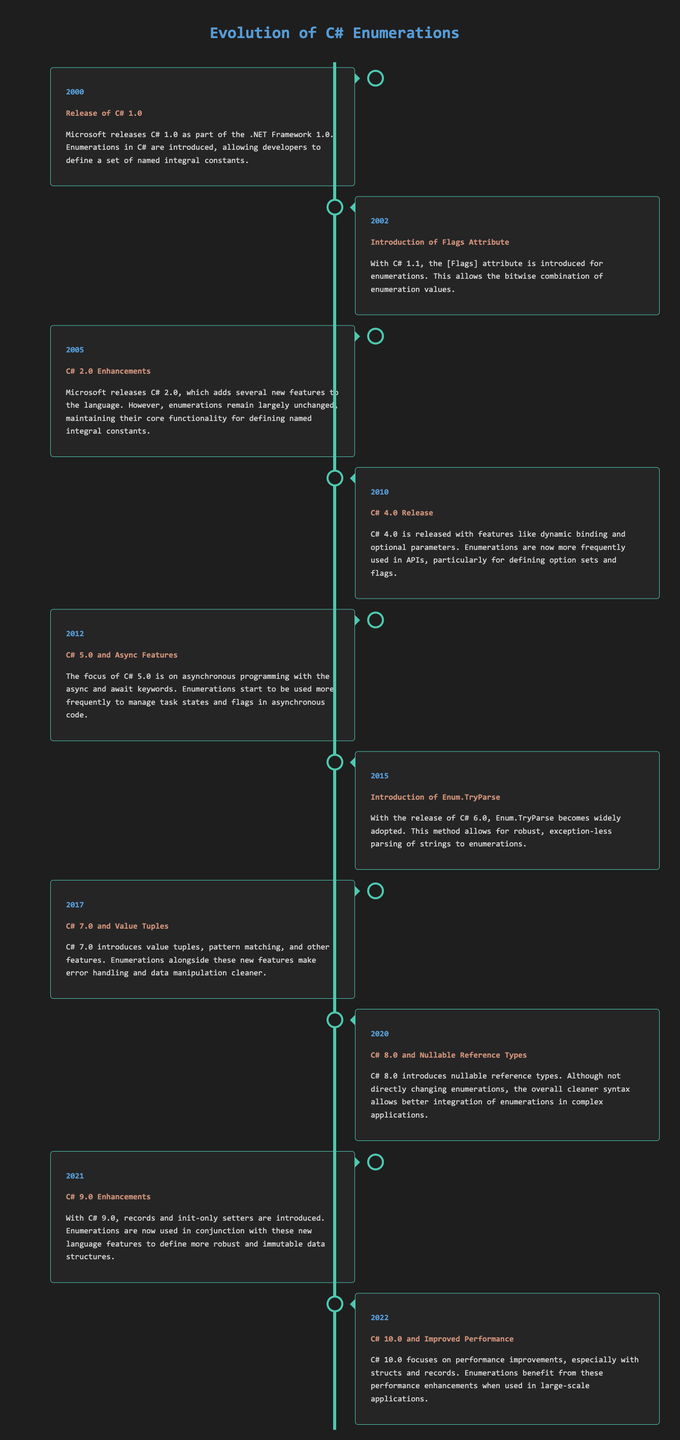What year was C# 1.0 released? C# 1.0 was released in the year mentioned in the timeline, specifically in 2000.
Answer: 2000 What feature was introduced in 2002 related to enumerations? The timeline indicates that the Flags attribute was introduced for enumerations.
Answer: Flags attribute Which version of C# had Enum.TryParse introduced? According to the timeline, Enum.TryParse was introduced in the year of the C# 6.0 release.
Answer: C# 6.0 In what year did C# start to focus on asynchronous programming? The document states that the focus on asynchronous programming began with C# 5.0.
Answer: 2012 Which C# version introduced value tuples? The timeline mentions that value tuples were introduced in C# 7.0.
Answer: C# 7.0 What key feature did C# 10.0 focus on? C# 10.0 was focused on performance improvements, especially with structs and records.
Answer: Performance improvements Which two enhancements were introduced in C# 9.0? The timeline specifies that records and init-only setters were introduced in C# 9.0.
Answer: Records and init-only setters How did enumerations change with C# 4.0? The timeline notes that enumerations were used more frequently in APIs with C# 4.0.
Answer: Used more frequently in APIs What was a significant use of enumerations as stated in the C# 5.0 release? The document indicates that enumerations were used to manage task states and flags in asynchronous code.
Answer: Manage task states and flags 